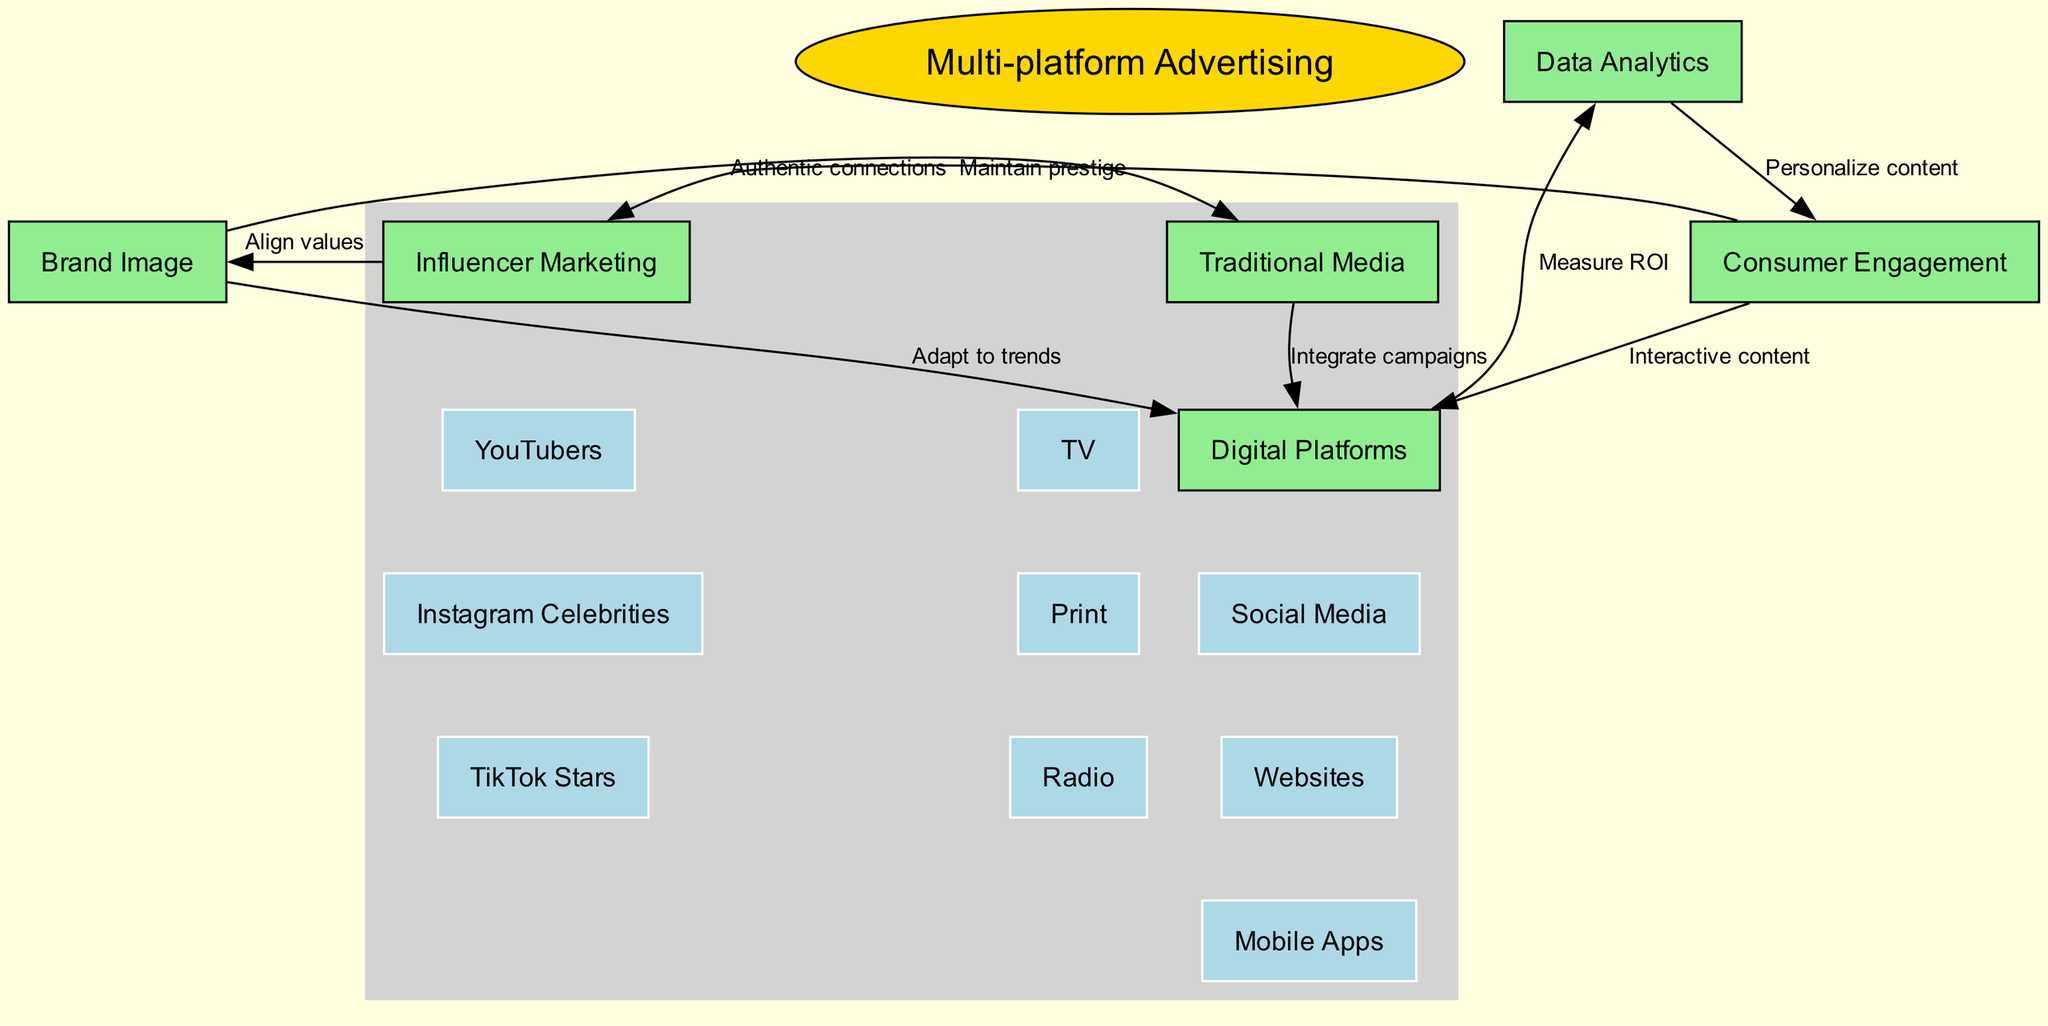What is the central concept of the diagram? The central concept is explicitly listed at the top of the diagram and is labeled as "Multi-platform Advertising."
Answer: Multi-platform Advertising How many main nodes are there in the diagram? There are six main nodes listed in the diagram: Brand Image, Consumer Engagement, Traditional Media, Digital Platforms, Influencer Marketing, and Data Analytics.
Answer: 6 What label connects Brand Image to Traditional Media? The connection from Brand Image to Traditional Media is labeled "Maintain prestige," indicating the relationship's purpose.
Answer: Maintain prestige Which sub-node is part of Traditional Media? One of the sub-nodes listed under Traditional Media is "TV," which represents a specific type of traditional media platform.
Answer: TV What is the relationship between Consumer Engagement and Data Analytics? The relationship is expressed through a connection labeled "Personalize content," indicating how data analytics aids in enhancing consumer engagement.
Answer: Personalize content How do Digital Platforms relate to Consumer Engagement? Digital Platforms are connected to Consumer Engagement by a label that states "Interactive content," signifying the type of engagement promoted through digital means.
Answer: Interactive content Which type of influencers are included under Influencer Marketing? The sub-nodes under Influencer Marketing include "YouTubers," "Instagram Celebrities," and "TikTok Stars," highlighting different influencer types utilized in marketing.
Answer: YouTubers, Instagram Celebrities, TikTok Stars What does Data Analytics measure in relation to Digital Platforms? Data Analytics is connected to Digital Platforms with the label "Measure ROI," which indicates the analytical focus on evaluating return on investment.
Answer: Measure ROI How does Influencer Marketing impact Brand Image? The connection is labeled "Align values," showing that influencer marketing aims to ensure that marketing efforts resonate with the brand's values.
Answer: Align values What is the flow of integration from Traditional Media to Digital Platforms? The labeled connection "Integrate campaigns" signifies that there is a flow intended for campaigns to be combined across Traditional Media and Digital Platforms.
Answer: Integrate campaigns 